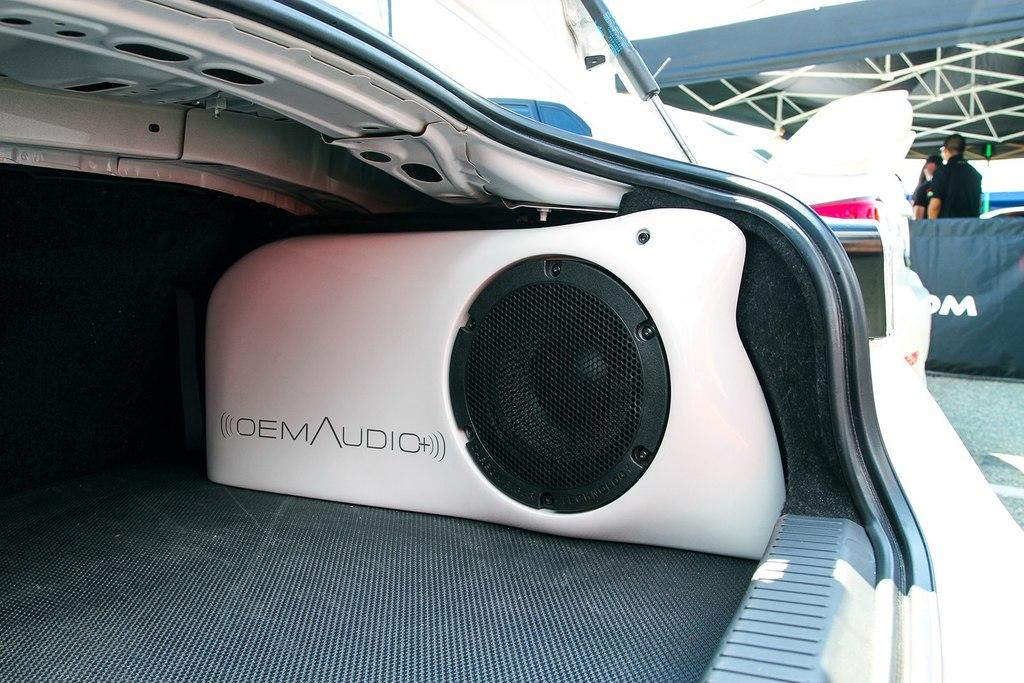What object is placed on a surface in the image? There is a speaker on a surface in the image. Can you describe the background of the image? In the background, there are two persons standing and a banner visible. There are also rods present. How many people can be seen in the image? There are two persons standing in the background. What type of button can be seen on the ground in the image? There is no button present on the ground in the image. Is there a house visible in the image? No, there is no house visible in the image. 